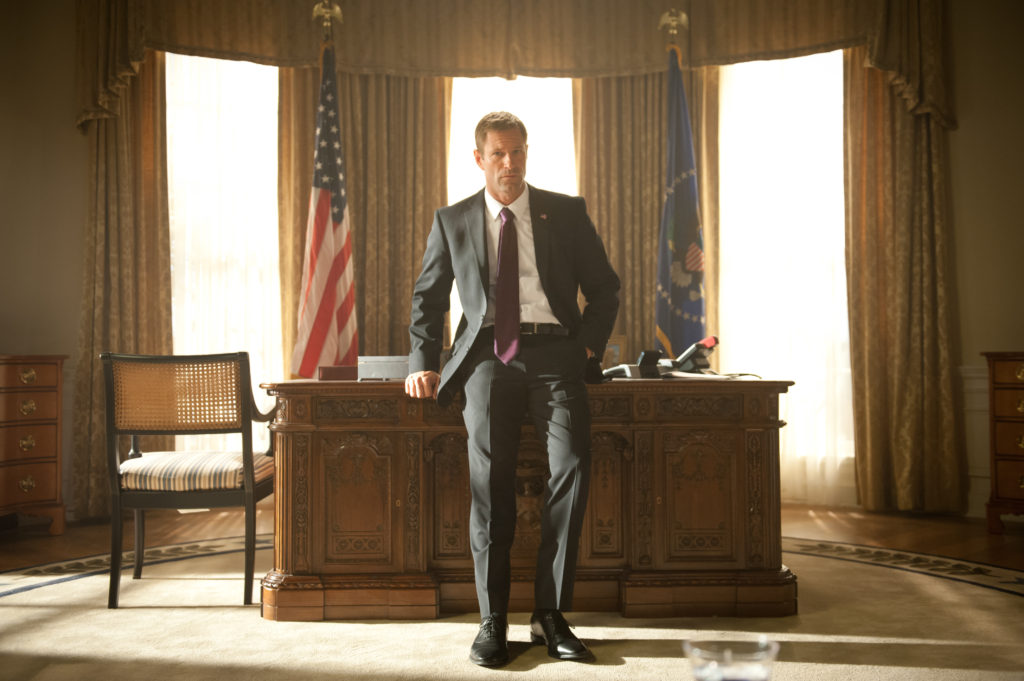What might be the historical significance of this room and its furnishings? This room, designed to emulate the Oval Office, carries immense historical significance. The desk, often referred to as the 'Resolute Desk,' is a symbol of presidential authority, with intricate carvings and a rich history dating back to its construction from the timbers of the British ship HMS Resolute. The American flag and the blue flag with a golden eagle symbolize national pride and the office's protective power. The room's decor, from the elegant drapes to the carefully chosen furnishings, speaks volumes about the heritage and continuity of leadership in the United States. It is a space where significant decisions affecting both national and global history are made, and its design reflects the weight of these responsibilities. 